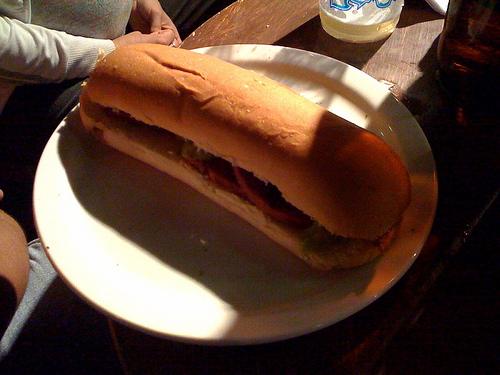Is this a sandwich?
Be succinct. Yes. Are there any sides with the sandwich?
Quick response, please. No. How many people are seen?
Give a very brief answer. 1. 